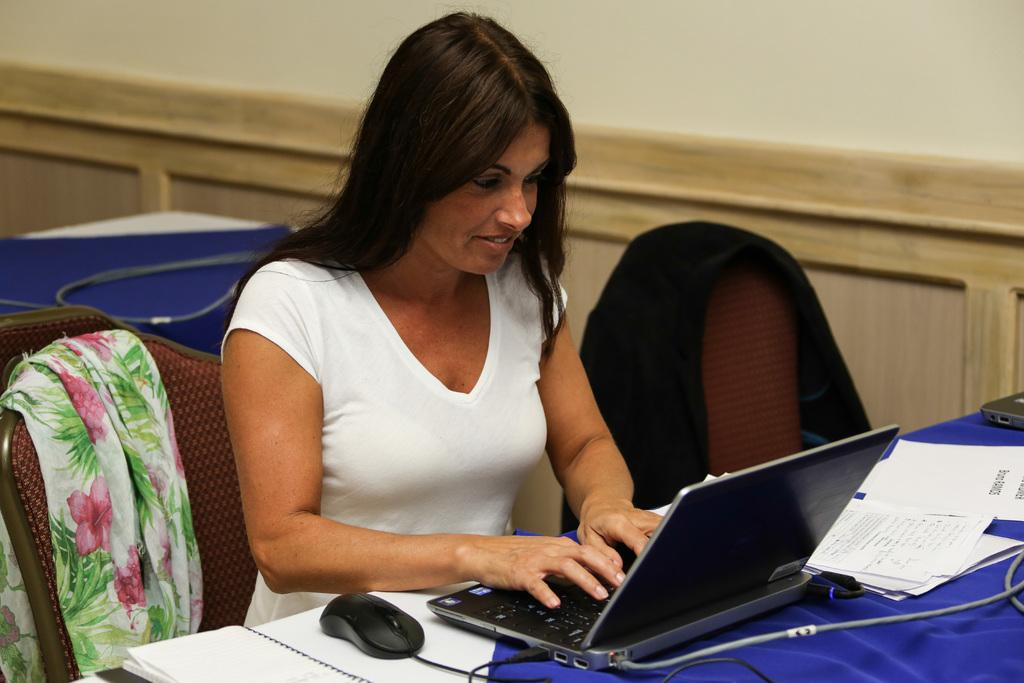What is the woman in the image wearing? The woman is wearing a white t-shirt. Where is the woman located in the image? The woman is sitting in front of a table. What objects can be seen on the table in the image? There is a laptop, a mouse, and books on the table. What is covering the chair the woman is sitting on? There is a cloth on the chair. What is visible beside the woman in the image? There is a wall beside the woman. What is the texture of the governor's theory in the image? There is no governor or theory present in the image. 